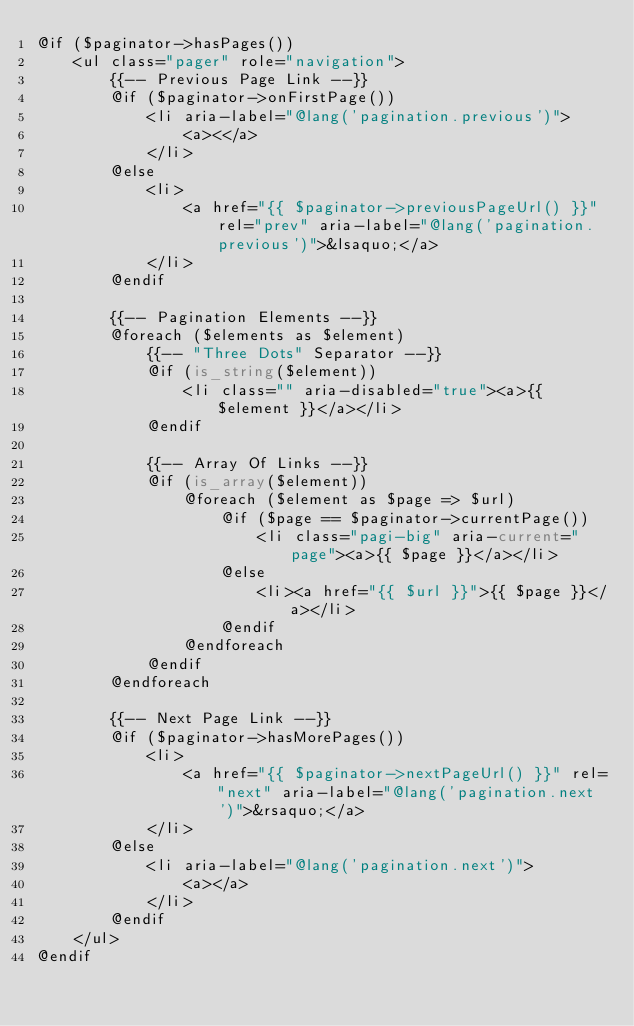Convert code to text. <code><loc_0><loc_0><loc_500><loc_500><_PHP_>@if ($paginator->hasPages())
    <ul class="pager" role="navigation">
        {{-- Previous Page Link --}}
        @if ($paginator->onFirstPage())
            <li aria-label="@lang('pagination.previous')">
                <a><</a>
            </li>
        @else
            <li>
                <a href="{{ $paginator->previousPageUrl() }}" rel="prev" aria-label="@lang('pagination.previous')">&lsaquo;</a>
            </li>
        @endif

        {{-- Pagination Elements --}}
        @foreach ($elements as $element)
            {{-- "Three Dots" Separator --}}
            @if (is_string($element))
                <li class="" aria-disabled="true"><a>{{ $element }}</a></li>
            @endif

            {{-- Array Of Links --}}
            @if (is_array($element))
                @foreach ($element as $page => $url)
                    @if ($page == $paginator->currentPage())
                        <li class="pagi-big" aria-current="page"><a>{{ $page }}</a></li>
                    @else
                        <li><a href="{{ $url }}">{{ $page }}</a></li>
                    @endif
                @endforeach
            @endif
        @endforeach

        {{-- Next Page Link --}}
        @if ($paginator->hasMorePages())
            <li>
                <a href="{{ $paginator->nextPageUrl() }}" rel="next" aria-label="@lang('pagination.next')">&rsaquo;</a>
            </li>
        @else
            <li aria-label="@lang('pagination.next')">
                <a></a>
            </li>
        @endif
    </ul>
@endif
</code> 